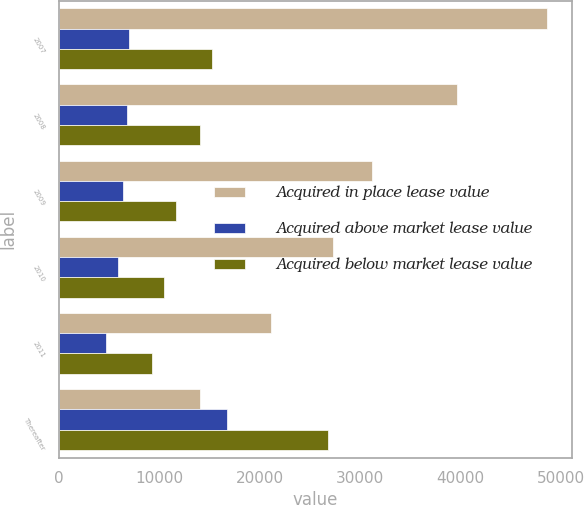<chart> <loc_0><loc_0><loc_500><loc_500><stacked_bar_chart><ecel><fcel>2007<fcel>2008<fcel>2009<fcel>2010<fcel>2011<fcel>Thereafter<nl><fcel>Acquired in place lease value<fcel>48637<fcel>39617<fcel>31201<fcel>27298<fcel>21076<fcel>14056<nl><fcel>Acquired above market lease value<fcel>6931<fcel>6735<fcel>6380<fcel>5869<fcel>4641<fcel>16736<nl><fcel>Acquired below market lease value<fcel>15284<fcel>14056<fcel>11668<fcel>10433<fcel>9268<fcel>26778<nl></chart> 